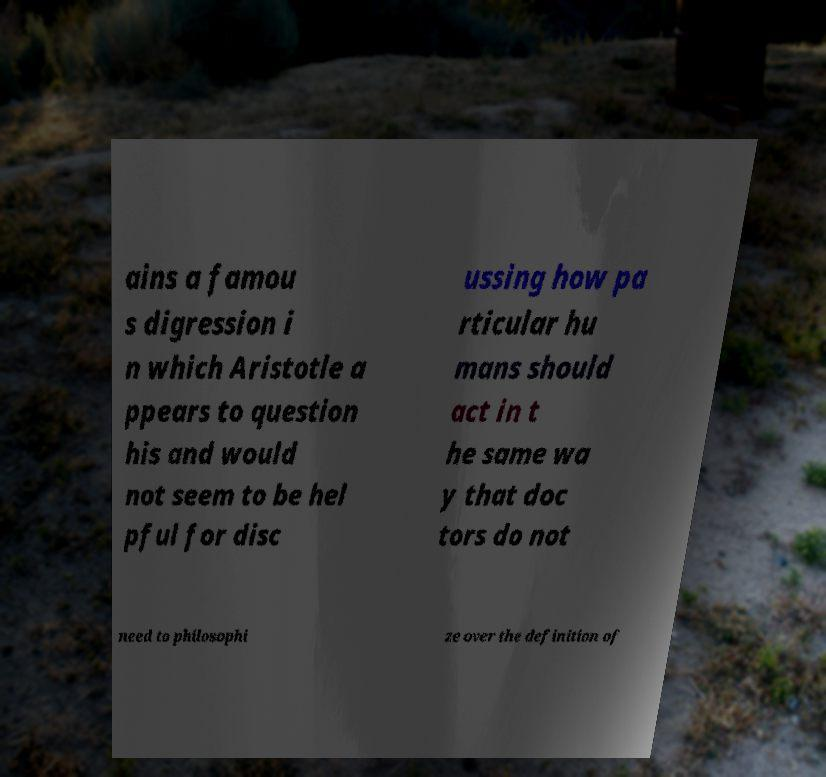There's text embedded in this image that I need extracted. Can you transcribe it verbatim? ains a famou s digression i n which Aristotle a ppears to question his and would not seem to be hel pful for disc ussing how pa rticular hu mans should act in t he same wa y that doc tors do not need to philosophi ze over the definition of 